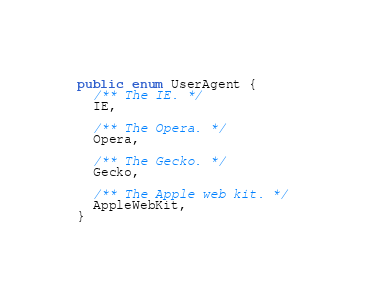<code> <loc_0><loc_0><loc_500><loc_500><_Java_>public enum UserAgent {
  /** The IE. */
  IE,

  /** The Opera. */
  Opera,

  /** The Gecko. */
  Gecko,

  /** The Apple web kit. */
  AppleWebKit,
}
</code> 